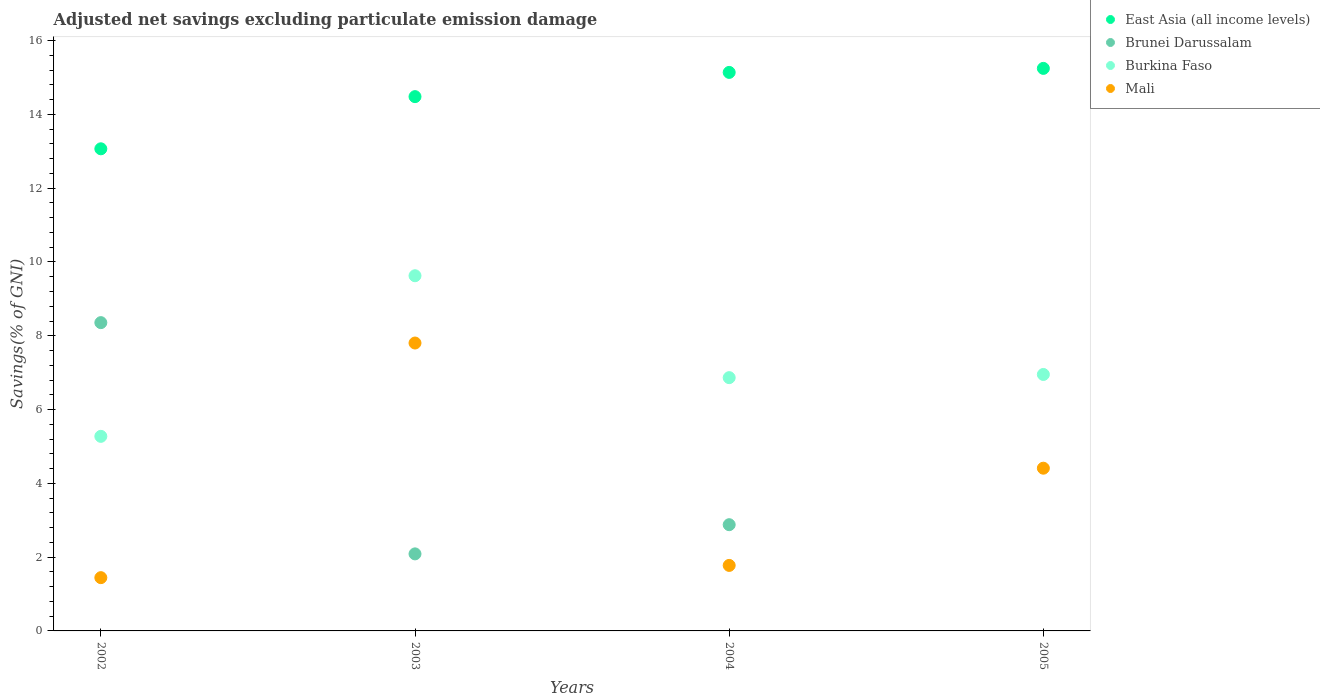What is the adjusted net savings in Brunei Darussalam in 2004?
Offer a terse response. 2.88. Across all years, what is the maximum adjusted net savings in Burkina Faso?
Your response must be concise. 9.63. Across all years, what is the minimum adjusted net savings in Burkina Faso?
Give a very brief answer. 5.27. What is the total adjusted net savings in Burkina Faso in the graph?
Make the answer very short. 28.72. What is the difference between the adjusted net savings in East Asia (all income levels) in 2004 and that in 2005?
Make the answer very short. -0.11. What is the difference between the adjusted net savings in Burkina Faso in 2004 and the adjusted net savings in East Asia (all income levels) in 2005?
Keep it short and to the point. -8.38. What is the average adjusted net savings in Burkina Faso per year?
Ensure brevity in your answer.  7.18. In the year 2002, what is the difference between the adjusted net savings in Brunei Darussalam and adjusted net savings in Mali?
Provide a succinct answer. 6.91. What is the ratio of the adjusted net savings in Brunei Darussalam in 2002 to that in 2004?
Offer a very short reply. 2.9. Is the adjusted net savings in Mali in 2002 less than that in 2005?
Your answer should be compact. Yes. What is the difference between the highest and the second highest adjusted net savings in Brunei Darussalam?
Ensure brevity in your answer.  5.48. What is the difference between the highest and the lowest adjusted net savings in East Asia (all income levels)?
Offer a very short reply. 2.18. Is the adjusted net savings in Brunei Darussalam strictly greater than the adjusted net savings in East Asia (all income levels) over the years?
Ensure brevity in your answer.  No. How many years are there in the graph?
Your answer should be compact. 4. What is the difference between two consecutive major ticks on the Y-axis?
Your response must be concise. 2. Does the graph contain any zero values?
Provide a short and direct response. Yes. Does the graph contain grids?
Ensure brevity in your answer.  No. What is the title of the graph?
Your answer should be very brief. Adjusted net savings excluding particulate emission damage. What is the label or title of the Y-axis?
Your response must be concise. Savings(% of GNI). What is the Savings(% of GNI) of East Asia (all income levels) in 2002?
Provide a short and direct response. 13.07. What is the Savings(% of GNI) of Brunei Darussalam in 2002?
Your answer should be very brief. 8.36. What is the Savings(% of GNI) in Burkina Faso in 2002?
Your answer should be very brief. 5.27. What is the Savings(% of GNI) in Mali in 2002?
Ensure brevity in your answer.  1.44. What is the Savings(% of GNI) of East Asia (all income levels) in 2003?
Make the answer very short. 14.48. What is the Savings(% of GNI) of Brunei Darussalam in 2003?
Offer a very short reply. 2.09. What is the Savings(% of GNI) of Burkina Faso in 2003?
Your response must be concise. 9.63. What is the Savings(% of GNI) of Mali in 2003?
Ensure brevity in your answer.  7.8. What is the Savings(% of GNI) in East Asia (all income levels) in 2004?
Your answer should be very brief. 15.14. What is the Savings(% of GNI) in Brunei Darussalam in 2004?
Your response must be concise. 2.88. What is the Savings(% of GNI) of Burkina Faso in 2004?
Offer a very short reply. 6.86. What is the Savings(% of GNI) of Mali in 2004?
Provide a short and direct response. 1.78. What is the Savings(% of GNI) in East Asia (all income levels) in 2005?
Keep it short and to the point. 15.25. What is the Savings(% of GNI) in Brunei Darussalam in 2005?
Your response must be concise. 0. What is the Savings(% of GNI) in Burkina Faso in 2005?
Provide a succinct answer. 6.95. What is the Savings(% of GNI) of Mali in 2005?
Provide a succinct answer. 4.41. Across all years, what is the maximum Savings(% of GNI) of East Asia (all income levels)?
Give a very brief answer. 15.25. Across all years, what is the maximum Savings(% of GNI) in Brunei Darussalam?
Ensure brevity in your answer.  8.36. Across all years, what is the maximum Savings(% of GNI) in Burkina Faso?
Give a very brief answer. 9.63. Across all years, what is the maximum Savings(% of GNI) in Mali?
Give a very brief answer. 7.8. Across all years, what is the minimum Savings(% of GNI) of East Asia (all income levels)?
Give a very brief answer. 13.07. Across all years, what is the minimum Savings(% of GNI) in Brunei Darussalam?
Your answer should be very brief. 0. Across all years, what is the minimum Savings(% of GNI) in Burkina Faso?
Provide a succinct answer. 5.27. Across all years, what is the minimum Savings(% of GNI) of Mali?
Your response must be concise. 1.44. What is the total Savings(% of GNI) of East Asia (all income levels) in the graph?
Make the answer very short. 57.93. What is the total Savings(% of GNI) in Brunei Darussalam in the graph?
Keep it short and to the point. 13.32. What is the total Savings(% of GNI) in Burkina Faso in the graph?
Keep it short and to the point. 28.72. What is the total Savings(% of GNI) of Mali in the graph?
Your response must be concise. 15.43. What is the difference between the Savings(% of GNI) in East Asia (all income levels) in 2002 and that in 2003?
Your response must be concise. -1.41. What is the difference between the Savings(% of GNI) of Brunei Darussalam in 2002 and that in 2003?
Provide a succinct answer. 6.27. What is the difference between the Savings(% of GNI) in Burkina Faso in 2002 and that in 2003?
Your response must be concise. -4.35. What is the difference between the Savings(% of GNI) in Mali in 2002 and that in 2003?
Give a very brief answer. -6.36. What is the difference between the Savings(% of GNI) of East Asia (all income levels) in 2002 and that in 2004?
Provide a short and direct response. -2.07. What is the difference between the Savings(% of GNI) in Brunei Darussalam in 2002 and that in 2004?
Provide a succinct answer. 5.48. What is the difference between the Savings(% of GNI) of Burkina Faso in 2002 and that in 2004?
Make the answer very short. -1.59. What is the difference between the Savings(% of GNI) of Mali in 2002 and that in 2004?
Your answer should be very brief. -0.33. What is the difference between the Savings(% of GNI) in East Asia (all income levels) in 2002 and that in 2005?
Provide a short and direct response. -2.18. What is the difference between the Savings(% of GNI) of Burkina Faso in 2002 and that in 2005?
Give a very brief answer. -1.68. What is the difference between the Savings(% of GNI) of Mali in 2002 and that in 2005?
Your answer should be compact. -2.97. What is the difference between the Savings(% of GNI) in East Asia (all income levels) in 2003 and that in 2004?
Offer a terse response. -0.66. What is the difference between the Savings(% of GNI) of Brunei Darussalam in 2003 and that in 2004?
Offer a very short reply. -0.79. What is the difference between the Savings(% of GNI) in Burkina Faso in 2003 and that in 2004?
Provide a short and direct response. 2.76. What is the difference between the Savings(% of GNI) in Mali in 2003 and that in 2004?
Your answer should be compact. 6.03. What is the difference between the Savings(% of GNI) of East Asia (all income levels) in 2003 and that in 2005?
Offer a very short reply. -0.77. What is the difference between the Savings(% of GNI) of Burkina Faso in 2003 and that in 2005?
Offer a terse response. 2.68. What is the difference between the Savings(% of GNI) of Mali in 2003 and that in 2005?
Provide a succinct answer. 3.39. What is the difference between the Savings(% of GNI) in East Asia (all income levels) in 2004 and that in 2005?
Make the answer very short. -0.11. What is the difference between the Savings(% of GNI) of Burkina Faso in 2004 and that in 2005?
Offer a terse response. -0.09. What is the difference between the Savings(% of GNI) of Mali in 2004 and that in 2005?
Make the answer very short. -2.63. What is the difference between the Savings(% of GNI) in East Asia (all income levels) in 2002 and the Savings(% of GNI) in Brunei Darussalam in 2003?
Make the answer very short. 10.98. What is the difference between the Savings(% of GNI) in East Asia (all income levels) in 2002 and the Savings(% of GNI) in Burkina Faso in 2003?
Your answer should be compact. 3.44. What is the difference between the Savings(% of GNI) of East Asia (all income levels) in 2002 and the Savings(% of GNI) of Mali in 2003?
Your response must be concise. 5.26. What is the difference between the Savings(% of GNI) in Brunei Darussalam in 2002 and the Savings(% of GNI) in Burkina Faso in 2003?
Provide a succinct answer. -1.27. What is the difference between the Savings(% of GNI) in Brunei Darussalam in 2002 and the Savings(% of GNI) in Mali in 2003?
Give a very brief answer. 0.55. What is the difference between the Savings(% of GNI) in Burkina Faso in 2002 and the Savings(% of GNI) in Mali in 2003?
Give a very brief answer. -2.53. What is the difference between the Savings(% of GNI) in East Asia (all income levels) in 2002 and the Savings(% of GNI) in Brunei Darussalam in 2004?
Provide a short and direct response. 10.19. What is the difference between the Savings(% of GNI) of East Asia (all income levels) in 2002 and the Savings(% of GNI) of Burkina Faso in 2004?
Provide a succinct answer. 6.2. What is the difference between the Savings(% of GNI) in East Asia (all income levels) in 2002 and the Savings(% of GNI) in Mali in 2004?
Provide a succinct answer. 11.29. What is the difference between the Savings(% of GNI) in Brunei Darussalam in 2002 and the Savings(% of GNI) in Burkina Faso in 2004?
Offer a terse response. 1.49. What is the difference between the Savings(% of GNI) of Brunei Darussalam in 2002 and the Savings(% of GNI) of Mali in 2004?
Offer a very short reply. 6.58. What is the difference between the Savings(% of GNI) of Burkina Faso in 2002 and the Savings(% of GNI) of Mali in 2004?
Your answer should be compact. 3.5. What is the difference between the Savings(% of GNI) of East Asia (all income levels) in 2002 and the Savings(% of GNI) of Burkina Faso in 2005?
Provide a short and direct response. 6.12. What is the difference between the Savings(% of GNI) in East Asia (all income levels) in 2002 and the Savings(% of GNI) in Mali in 2005?
Your response must be concise. 8.66. What is the difference between the Savings(% of GNI) of Brunei Darussalam in 2002 and the Savings(% of GNI) of Burkina Faso in 2005?
Offer a terse response. 1.4. What is the difference between the Savings(% of GNI) in Brunei Darussalam in 2002 and the Savings(% of GNI) in Mali in 2005?
Offer a terse response. 3.95. What is the difference between the Savings(% of GNI) in Burkina Faso in 2002 and the Savings(% of GNI) in Mali in 2005?
Offer a terse response. 0.86. What is the difference between the Savings(% of GNI) of East Asia (all income levels) in 2003 and the Savings(% of GNI) of Brunei Darussalam in 2004?
Ensure brevity in your answer.  11.6. What is the difference between the Savings(% of GNI) in East Asia (all income levels) in 2003 and the Savings(% of GNI) in Burkina Faso in 2004?
Provide a short and direct response. 7.62. What is the difference between the Savings(% of GNI) in East Asia (all income levels) in 2003 and the Savings(% of GNI) in Mali in 2004?
Your response must be concise. 12.71. What is the difference between the Savings(% of GNI) in Brunei Darussalam in 2003 and the Savings(% of GNI) in Burkina Faso in 2004?
Give a very brief answer. -4.78. What is the difference between the Savings(% of GNI) in Brunei Darussalam in 2003 and the Savings(% of GNI) in Mali in 2004?
Offer a terse response. 0.31. What is the difference between the Savings(% of GNI) of Burkina Faso in 2003 and the Savings(% of GNI) of Mali in 2004?
Ensure brevity in your answer.  7.85. What is the difference between the Savings(% of GNI) of East Asia (all income levels) in 2003 and the Savings(% of GNI) of Burkina Faso in 2005?
Provide a succinct answer. 7.53. What is the difference between the Savings(% of GNI) in East Asia (all income levels) in 2003 and the Savings(% of GNI) in Mali in 2005?
Offer a very short reply. 10.07. What is the difference between the Savings(% of GNI) of Brunei Darussalam in 2003 and the Savings(% of GNI) of Burkina Faso in 2005?
Your response must be concise. -4.86. What is the difference between the Savings(% of GNI) in Brunei Darussalam in 2003 and the Savings(% of GNI) in Mali in 2005?
Offer a terse response. -2.32. What is the difference between the Savings(% of GNI) of Burkina Faso in 2003 and the Savings(% of GNI) of Mali in 2005?
Provide a succinct answer. 5.22. What is the difference between the Savings(% of GNI) of East Asia (all income levels) in 2004 and the Savings(% of GNI) of Burkina Faso in 2005?
Give a very brief answer. 8.19. What is the difference between the Savings(% of GNI) of East Asia (all income levels) in 2004 and the Savings(% of GNI) of Mali in 2005?
Ensure brevity in your answer.  10.73. What is the difference between the Savings(% of GNI) in Brunei Darussalam in 2004 and the Savings(% of GNI) in Burkina Faso in 2005?
Your response must be concise. -4.07. What is the difference between the Savings(% of GNI) in Brunei Darussalam in 2004 and the Savings(% of GNI) in Mali in 2005?
Provide a succinct answer. -1.53. What is the difference between the Savings(% of GNI) in Burkina Faso in 2004 and the Savings(% of GNI) in Mali in 2005?
Keep it short and to the point. 2.45. What is the average Savings(% of GNI) in East Asia (all income levels) per year?
Make the answer very short. 14.48. What is the average Savings(% of GNI) in Brunei Darussalam per year?
Offer a terse response. 3.33. What is the average Savings(% of GNI) of Burkina Faso per year?
Your response must be concise. 7.18. What is the average Savings(% of GNI) in Mali per year?
Make the answer very short. 3.86. In the year 2002, what is the difference between the Savings(% of GNI) in East Asia (all income levels) and Savings(% of GNI) in Brunei Darussalam?
Your answer should be compact. 4.71. In the year 2002, what is the difference between the Savings(% of GNI) in East Asia (all income levels) and Savings(% of GNI) in Burkina Faso?
Ensure brevity in your answer.  7.79. In the year 2002, what is the difference between the Savings(% of GNI) in East Asia (all income levels) and Savings(% of GNI) in Mali?
Your answer should be compact. 11.62. In the year 2002, what is the difference between the Savings(% of GNI) in Brunei Darussalam and Savings(% of GNI) in Burkina Faso?
Provide a succinct answer. 3.08. In the year 2002, what is the difference between the Savings(% of GNI) in Brunei Darussalam and Savings(% of GNI) in Mali?
Provide a short and direct response. 6.91. In the year 2002, what is the difference between the Savings(% of GNI) of Burkina Faso and Savings(% of GNI) of Mali?
Your response must be concise. 3.83. In the year 2003, what is the difference between the Savings(% of GNI) in East Asia (all income levels) and Savings(% of GNI) in Brunei Darussalam?
Keep it short and to the point. 12.39. In the year 2003, what is the difference between the Savings(% of GNI) in East Asia (all income levels) and Savings(% of GNI) in Burkina Faso?
Give a very brief answer. 4.85. In the year 2003, what is the difference between the Savings(% of GNI) of East Asia (all income levels) and Savings(% of GNI) of Mali?
Offer a very short reply. 6.68. In the year 2003, what is the difference between the Savings(% of GNI) in Brunei Darussalam and Savings(% of GNI) in Burkina Faso?
Keep it short and to the point. -7.54. In the year 2003, what is the difference between the Savings(% of GNI) in Brunei Darussalam and Savings(% of GNI) in Mali?
Provide a short and direct response. -5.71. In the year 2003, what is the difference between the Savings(% of GNI) in Burkina Faso and Savings(% of GNI) in Mali?
Your answer should be compact. 1.82. In the year 2004, what is the difference between the Savings(% of GNI) in East Asia (all income levels) and Savings(% of GNI) in Brunei Darussalam?
Provide a succinct answer. 12.26. In the year 2004, what is the difference between the Savings(% of GNI) in East Asia (all income levels) and Savings(% of GNI) in Burkina Faso?
Offer a terse response. 8.27. In the year 2004, what is the difference between the Savings(% of GNI) in East Asia (all income levels) and Savings(% of GNI) in Mali?
Keep it short and to the point. 13.36. In the year 2004, what is the difference between the Savings(% of GNI) of Brunei Darussalam and Savings(% of GNI) of Burkina Faso?
Provide a short and direct response. -3.99. In the year 2004, what is the difference between the Savings(% of GNI) of Brunei Darussalam and Savings(% of GNI) of Mali?
Provide a succinct answer. 1.1. In the year 2004, what is the difference between the Savings(% of GNI) of Burkina Faso and Savings(% of GNI) of Mali?
Give a very brief answer. 5.09. In the year 2005, what is the difference between the Savings(% of GNI) in East Asia (all income levels) and Savings(% of GNI) in Burkina Faso?
Give a very brief answer. 8.3. In the year 2005, what is the difference between the Savings(% of GNI) in East Asia (all income levels) and Savings(% of GNI) in Mali?
Offer a terse response. 10.84. In the year 2005, what is the difference between the Savings(% of GNI) of Burkina Faso and Savings(% of GNI) of Mali?
Your answer should be very brief. 2.54. What is the ratio of the Savings(% of GNI) of East Asia (all income levels) in 2002 to that in 2003?
Your answer should be compact. 0.9. What is the ratio of the Savings(% of GNI) of Brunei Darussalam in 2002 to that in 2003?
Offer a terse response. 4. What is the ratio of the Savings(% of GNI) of Burkina Faso in 2002 to that in 2003?
Your response must be concise. 0.55. What is the ratio of the Savings(% of GNI) of Mali in 2002 to that in 2003?
Offer a very short reply. 0.18. What is the ratio of the Savings(% of GNI) in East Asia (all income levels) in 2002 to that in 2004?
Ensure brevity in your answer.  0.86. What is the ratio of the Savings(% of GNI) of Brunei Darussalam in 2002 to that in 2004?
Offer a very short reply. 2.9. What is the ratio of the Savings(% of GNI) of Burkina Faso in 2002 to that in 2004?
Offer a very short reply. 0.77. What is the ratio of the Savings(% of GNI) of Mali in 2002 to that in 2004?
Offer a very short reply. 0.81. What is the ratio of the Savings(% of GNI) of East Asia (all income levels) in 2002 to that in 2005?
Make the answer very short. 0.86. What is the ratio of the Savings(% of GNI) in Burkina Faso in 2002 to that in 2005?
Your answer should be compact. 0.76. What is the ratio of the Savings(% of GNI) in Mali in 2002 to that in 2005?
Provide a short and direct response. 0.33. What is the ratio of the Savings(% of GNI) of East Asia (all income levels) in 2003 to that in 2004?
Provide a succinct answer. 0.96. What is the ratio of the Savings(% of GNI) of Brunei Darussalam in 2003 to that in 2004?
Provide a succinct answer. 0.73. What is the ratio of the Savings(% of GNI) in Burkina Faso in 2003 to that in 2004?
Provide a succinct answer. 1.4. What is the ratio of the Savings(% of GNI) of Mali in 2003 to that in 2004?
Ensure brevity in your answer.  4.39. What is the ratio of the Savings(% of GNI) in East Asia (all income levels) in 2003 to that in 2005?
Keep it short and to the point. 0.95. What is the ratio of the Savings(% of GNI) of Burkina Faso in 2003 to that in 2005?
Give a very brief answer. 1.39. What is the ratio of the Savings(% of GNI) of Mali in 2003 to that in 2005?
Provide a short and direct response. 1.77. What is the ratio of the Savings(% of GNI) in Burkina Faso in 2004 to that in 2005?
Your response must be concise. 0.99. What is the ratio of the Savings(% of GNI) in Mali in 2004 to that in 2005?
Your answer should be compact. 0.4. What is the difference between the highest and the second highest Savings(% of GNI) in East Asia (all income levels)?
Give a very brief answer. 0.11. What is the difference between the highest and the second highest Savings(% of GNI) in Brunei Darussalam?
Offer a terse response. 5.48. What is the difference between the highest and the second highest Savings(% of GNI) in Burkina Faso?
Your response must be concise. 2.68. What is the difference between the highest and the second highest Savings(% of GNI) in Mali?
Provide a succinct answer. 3.39. What is the difference between the highest and the lowest Savings(% of GNI) of East Asia (all income levels)?
Your answer should be very brief. 2.18. What is the difference between the highest and the lowest Savings(% of GNI) of Brunei Darussalam?
Your response must be concise. 8.36. What is the difference between the highest and the lowest Savings(% of GNI) of Burkina Faso?
Your answer should be very brief. 4.35. What is the difference between the highest and the lowest Savings(% of GNI) in Mali?
Keep it short and to the point. 6.36. 